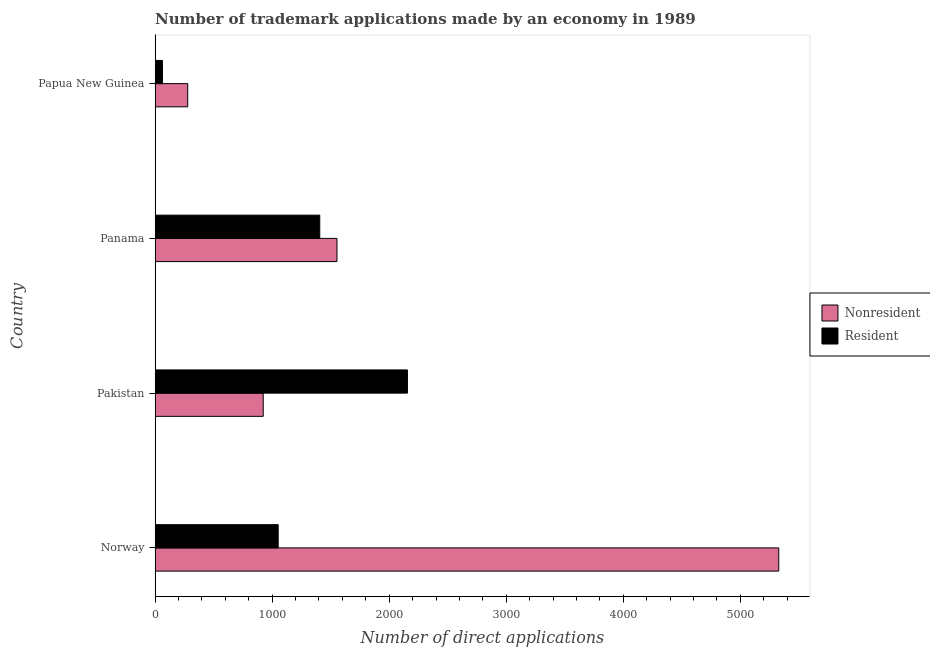How many different coloured bars are there?
Offer a very short reply. 2. Are the number of bars per tick equal to the number of legend labels?
Offer a very short reply. Yes. What is the label of the 4th group of bars from the top?
Your response must be concise. Norway. In how many cases, is the number of bars for a given country not equal to the number of legend labels?
Provide a succinct answer. 0. What is the number of trademark applications made by residents in Pakistan?
Give a very brief answer. 2156. Across all countries, what is the maximum number of trademark applications made by non residents?
Give a very brief answer. 5328. Across all countries, what is the minimum number of trademark applications made by non residents?
Your answer should be very brief. 279. In which country was the number of trademark applications made by non residents maximum?
Your answer should be compact. Norway. In which country was the number of trademark applications made by non residents minimum?
Keep it short and to the point. Papua New Guinea. What is the total number of trademark applications made by residents in the graph?
Provide a short and direct response. 4678. What is the difference between the number of trademark applications made by non residents in Norway and that in Pakistan?
Offer a terse response. 4404. What is the difference between the number of trademark applications made by residents in Norway and the number of trademark applications made by non residents in Papua New Guinea?
Your answer should be compact. 773. What is the average number of trademark applications made by residents per country?
Keep it short and to the point. 1169.5. What is the difference between the number of trademark applications made by residents and number of trademark applications made by non residents in Norway?
Your answer should be very brief. -4276. In how many countries, is the number of trademark applications made by residents greater than 1600 ?
Your response must be concise. 1. What is the ratio of the number of trademark applications made by residents in Pakistan to that in Panama?
Provide a short and direct response. 1.53. Is the number of trademark applications made by non residents in Panama less than that in Papua New Guinea?
Give a very brief answer. No. What is the difference between the highest and the second highest number of trademark applications made by residents?
Ensure brevity in your answer.  749. What is the difference between the highest and the lowest number of trademark applications made by non residents?
Your answer should be very brief. 5049. What does the 2nd bar from the top in Norway represents?
Your answer should be very brief. Nonresident. What does the 1st bar from the bottom in Papua New Guinea represents?
Give a very brief answer. Nonresident. How many bars are there?
Offer a terse response. 8. How many countries are there in the graph?
Your response must be concise. 4. What is the difference between two consecutive major ticks on the X-axis?
Offer a terse response. 1000. Are the values on the major ticks of X-axis written in scientific E-notation?
Your response must be concise. No. Does the graph contain any zero values?
Provide a succinct answer. No. Where does the legend appear in the graph?
Offer a very short reply. Center right. How are the legend labels stacked?
Your answer should be very brief. Vertical. What is the title of the graph?
Make the answer very short. Number of trademark applications made by an economy in 1989. What is the label or title of the X-axis?
Make the answer very short. Number of direct applications. What is the Number of direct applications in Nonresident in Norway?
Offer a very short reply. 5328. What is the Number of direct applications in Resident in Norway?
Give a very brief answer. 1052. What is the Number of direct applications in Nonresident in Pakistan?
Ensure brevity in your answer.  924. What is the Number of direct applications of Resident in Pakistan?
Offer a terse response. 2156. What is the Number of direct applications of Nonresident in Panama?
Ensure brevity in your answer.  1554. What is the Number of direct applications in Resident in Panama?
Ensure brevity in your answer.  1407. What is the Number of direct applications of Nonresident in Papua New Guinea?
Make the answer very short. 279. Across all countries, what is the maximum Number of direct applications in Nonresident?
Ensure brevity in your answer.  5328. Across all countries, what is the maximum Number of direct applications in Resident?
Give a very brief answer. 2156. Across all countries, what is the minimum Number of direct applications in Nonresident?
Your answer should be compact. 279. What is the total Number of direct applications of Nonresident in the graph?
Ensure brevity in your answer.  8085. What is the total Number of direct applications in Resident in the graph?
Your answer should be very brief. 4678. What is the difference between the Number of direct applications in Nonresident in Norway and that in Pakistan?
Ensure brevity in your answer.  4404. What is the difference between the Number of direct applications in Resident in Norway and that in Pakistan?
Provide a short and direct response. -1104. What is the difference between the Number of direct applications in Nonresident in Norway and that in Panama?
Offer a very short reply. 3774. What is the difference between the Number of direct applications of Resident in Norway and that in Panama?
Provide a short and direct response. -355. What is the difference between the Number of direct applications in Nonresident in Norway and that in Papua New Guinea?
Your response must be concise. 5049. What is the difference between the Number of direct applications in Resident in Norway and that in Papua New Guinea?
Keep it short and to the point. 989. What is the difference between the Number of direct applications in Nonresident in Pakistan and that in Panama?
Ensure brevity in your answer.  -630. What is the difference between the Number of direct applications in Resident in Pakistan and that in Panama?
Your answer should be compact. 749. What is the difference between the Number of direct applications of Nonresident in Pakistan and that in Papua New Guinea?
Ensure brevity in your answer.  645. What is the difference between the Number of direct applications in Resident in Pakistan and that in Papua New Guinea?
Your response must be concise. 2093. What is the difference between the Number of direct applications in Nonresident in Panama and that in Papua New Guinea?
Provide a succinct answer. 1275. What is the difference between the Number of direct applications of Resident in Panama and that in Papua New Guinea?
Ensure brevity in your answer.  1344. What is the difference between the Number of direct applications of Nonresident in Norway and the Number of direct applications of Resident in Pakistan?
Ensure brevity in your answer.  3172. What is the difference between the Number of direct applications in Nonresident in Norway and the Number of direct applications in Resident in Panama?
Your answer should be very brief. 3921. What is the difference between the Number of direct applications of Nonresident in Norway and the Number of direct applications of Resident in Papua New Guinea?
Make the answer very short. 5265. What is the difference between the Number of direct applications in Nonresident in Pakistan and the Number of direct applications in Resident in Panama?
Give a very brief answer. -483. What is the difference between the Number of direct applications in Nonresident in Pakistan and the Number of direct applications in Resident in Papua New Guinea?
Give a very brief answer. 861. What is the difference between the Number of direct applications in Nonresident in Panama and the Number of direct applications in Resident in Papua New Guinea?
Offer a very short reply. 1491. What is the average Number of direct applications in Nonresident per country?
Offer a very short reply. 2021.25. What is the average Number of direct applications in Resident per country?
Provide a short and direct response. 1169.5. What is the difference between the Number of direct applications in Nonresident and Number of direct applications in Resident in Norway?
Your answer should be very brief. 4276. What is the difference between the Number of direct applications in Nonresident and Number of direct applications in Resident in Pakistan?
Make the answer very short. -1232. What is the difference between the Number of direct applications of Nonresident and Number of direct applications of Resident in Panama?
Your answer should be very brief. 147. What is the difference between the Number of direct applications in Nonresident and Number of direct applications in Resident in Papua New Guinea?
Provide a succinct answer. 216. What is the ratio of the Number of direct applications of Nonresident in Norway to that in Pakistan?
Your answer should be very brief. 5.77. What is the ratio of the Number of direct applications in Resident in Norway to that in Pakistan?
Offer a very short reply. 0.49. What is the ratio of the Number of direct applications of Nonresident in Norway to that in Panama?
Your answer should be compact. 3.43. What is the ratio of the Number of direct applications in Resident in Norway to that in Panama?
Your response must be concise. 0.75. What is the ratio of the Number of direct applications in Nonresident in Norway to that in Papua New Guinea?
Your answer should be compact. 19.1. What is the ratio of the Number of direct applications of Resident in Norway to that in Papua New Guinea?
Offer a terse response. 16.7. What is the ratio of the Number of direct applications in Nonresident in Pakistan to that in Panama?
Offer a terse response. 0.59. What is the ratio of the Number of direct applications of Resident in Pakistan to that in Panama?
Keep it short and to the point. 1.53. What is the ratio of the Number of direct applications in Nonresident in Pakistan to that in Papua New Guinea?
Your answer should be very brief. 3.31. What is the ratio of the Number of direct applications of Resident in Pakistan to that in Papua New Guinea?
Offer a very short reply. 34.22. What is the ratio of the Number of direct applications of Nonresident in Panama to that in Papua New Guinea?
Provide a short and direct response. 5.57. What is the ratio of the Number of direct applications in Resident in Panama to that in Papua New Guinea?
Your answer should be compact. 22.33. What is the difference between the highest and the second highest Number of direct applications of Nonresident?
Your answer should be very brief. 3774. What is the difference between the highest and the second highest Number of direct applications in Resident?
Give a very brief answer. 749. What is the difference between the highest and the lowest Number of direct applications in Nonresident?
Offer a terse response. 5049. What is the difference between the highest and the lowest Number of direct applications of Resident?
Ensure brevity in your answer.  2093. 